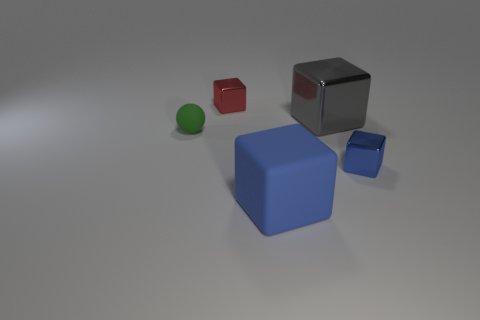Subtract all metal blocks. How many blocks are left? 1 Subtract all red spheres. How many blue blocks are left? 2 Subtract all gray blocks. How many blocks are left? 3 Subtract 1 cubes. How many cubes are left? 3 Subtract all red blocks. Subtract all yellow cylinders. How many blocks are left? 3 Add 3 big green metallic cylinders. How many objects exist? 8 Subtract all cubes. How many objects are left? 1 Add 2 blue shiny things. How many blue shiny things are left? 3 Add 4 large yellow shiny objects. How many large yellow shiny objects exist? 4 Subtract 0 brown spheres. How many objects are left? 5 